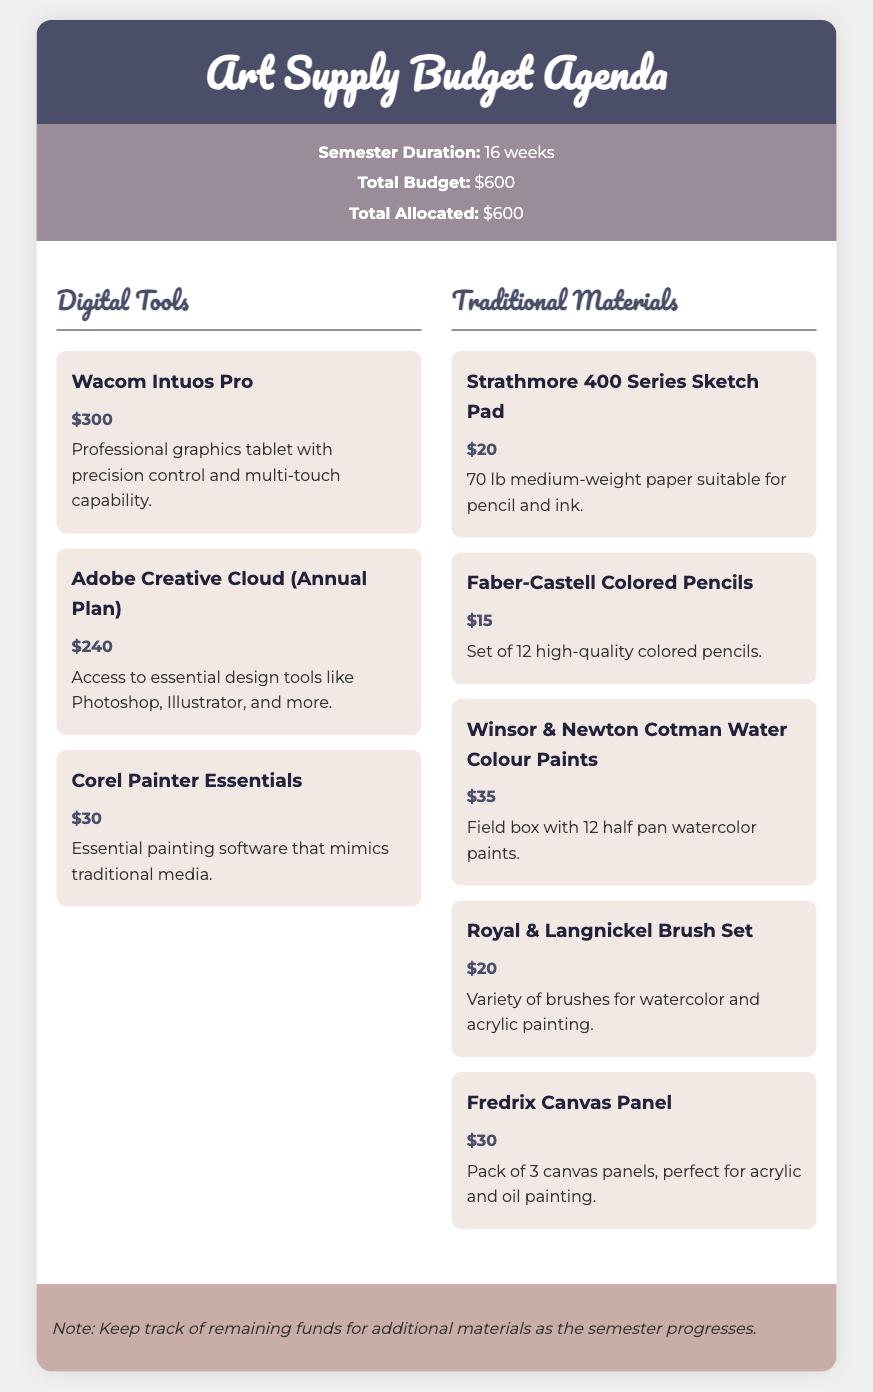What is the total budget for the semester? The total budget is explicitly stated in the document.
Answer: $600 How many weeks does the semester last? The duration of the semester is mentioned in the budget information section.
Answer: 16 weeks What is the cost of the Wacom Intuos Pro? The price of the Wacom Intuos Pro is listed under the digital tools section.
Answer: $300 What are the two main categories of supplies listed? The document provides information about the categories of supplies.
Answer: Digital Tools, Traditional Materials How much is allocated for Adobe Creative Cloud? The allocation for Adobe Creative Cloud is specified in the document.
Answer: $240 What traditional material costs the least? The prices of traditional materials allow for this determination.
Answer: Faber-Castell Colored Pencils What is the total amount allocated for traditional materials? The total for traditional materials must be calculated by summing individual costs listed.
Answer: $120 What note is included in the budget agenda? The document contains a specific note that provides additional advice regarding budget management.
Answer: Keep track of remaining funds for additional materials as the semester progresses How many items are listed under digital tools? The document explicitly lists the items under digital tools for review.
Answer: 3 items 